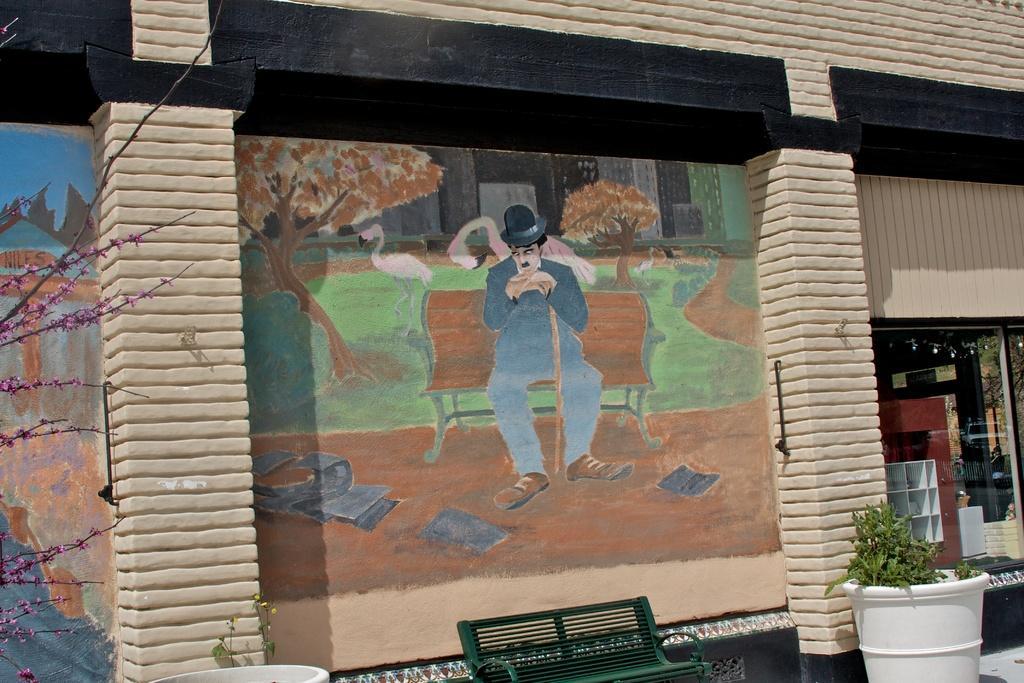Could you give a brief overview of what you see in this image? This picture is clicked outside. In the foreground we can see the white color potted plants and we can see the green color bench. In the background there is a wall and we can see the picture of a person sitting on the bench and we can see the picture of trees and some birds. On the left corner we can see the stems of a tree. On the right corner we can see a shutter and many other objects. 